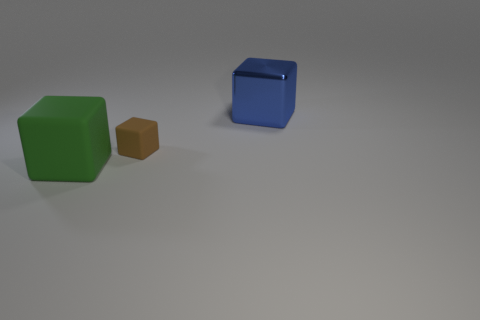What is the shape of the small brown object?
Your answer should be compact. Cube. How many other objects are there of the same material as the big blue block?
Offer a terse response. 0. The big thing that is on the right side of the big block in front of the matte block on the right side of the green rubber cube is what color?
Give a very brief answer. Blue. There is another thing that is the same size as the green object; what material is it?
Provide a succinct answer. Metal. What number of things are either big blocks that are in front of the metal block or large metallic blocks?
Ensure brevity in your answer.  2. Are any small red matte objects visible?
Make the answer very short. No. What is the large cube to the left of the large blue object made of?
Your answer should be compact. Rubber. What number of tiny objects are either brown cubes or blue things?
Ensure brevity in your answer.  1. What is the color of the metal cube?
Keep it short and to the point. Blue. There is a big block that is behind the green rubber object; is there a small brown object that is right of it?
Give a very brief answer. No. 